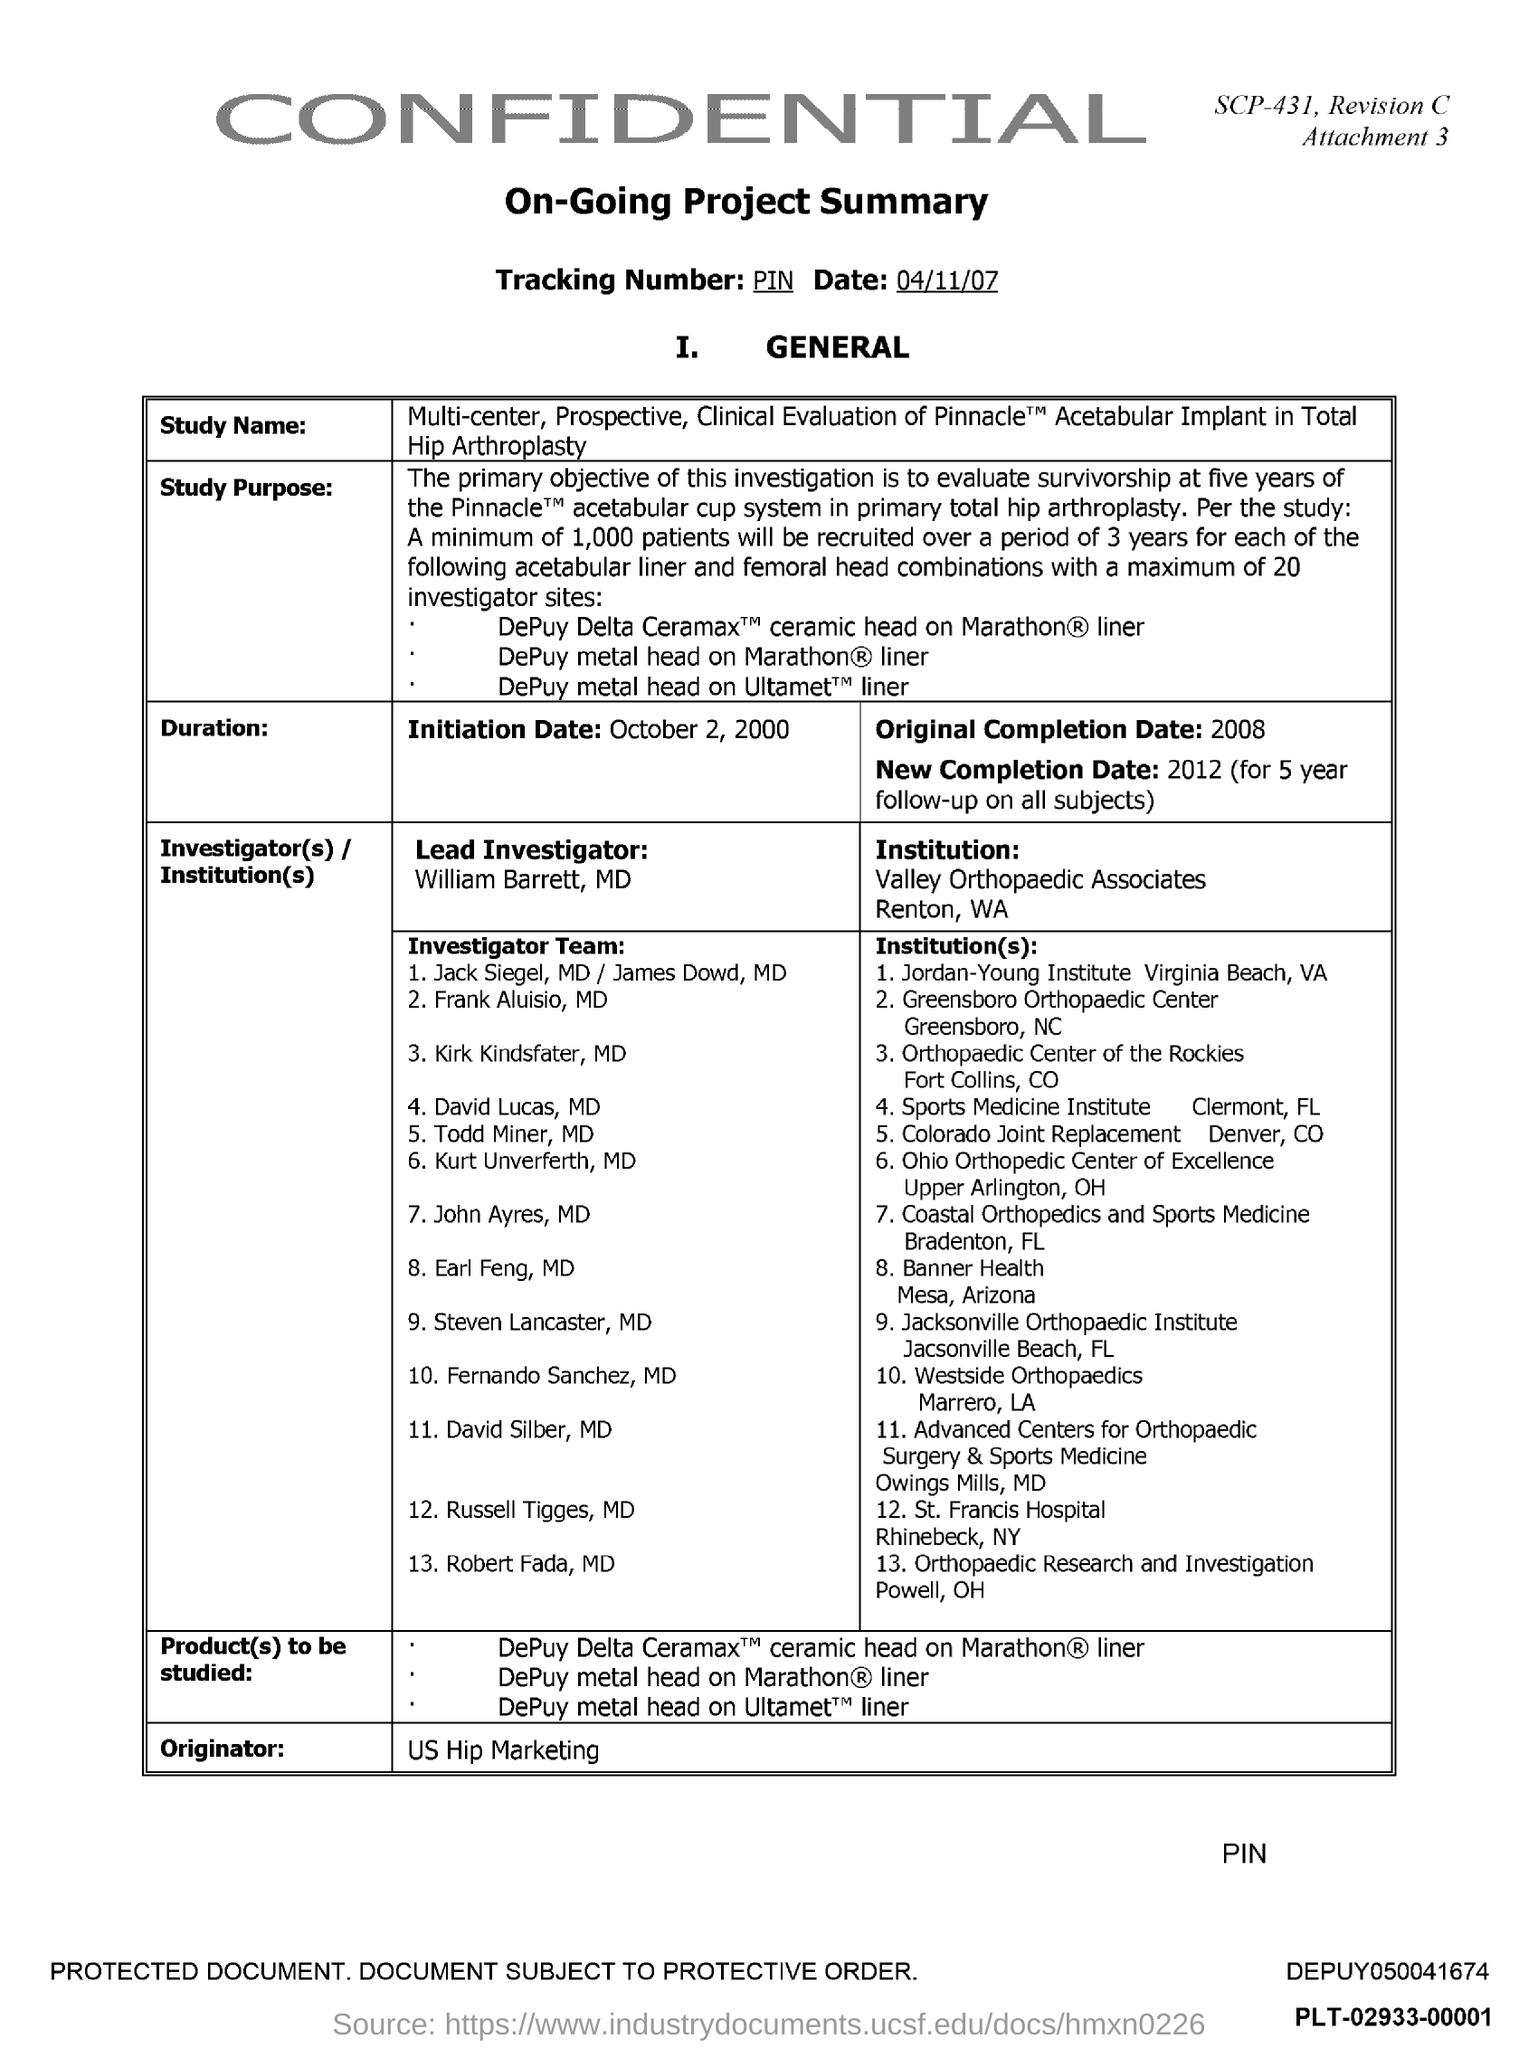Outline some significant characteristics in this image. The document mentions Valley Orthopaedic Associates, a prominent institution located in Renton, Washington. The tracking number provided in the document is PIN. The Originator mentioned in the document is US Hip Marketing. The original completion date mentioned in the document is 2008. The initiation date mentioned in the document is October 2, 2000. 